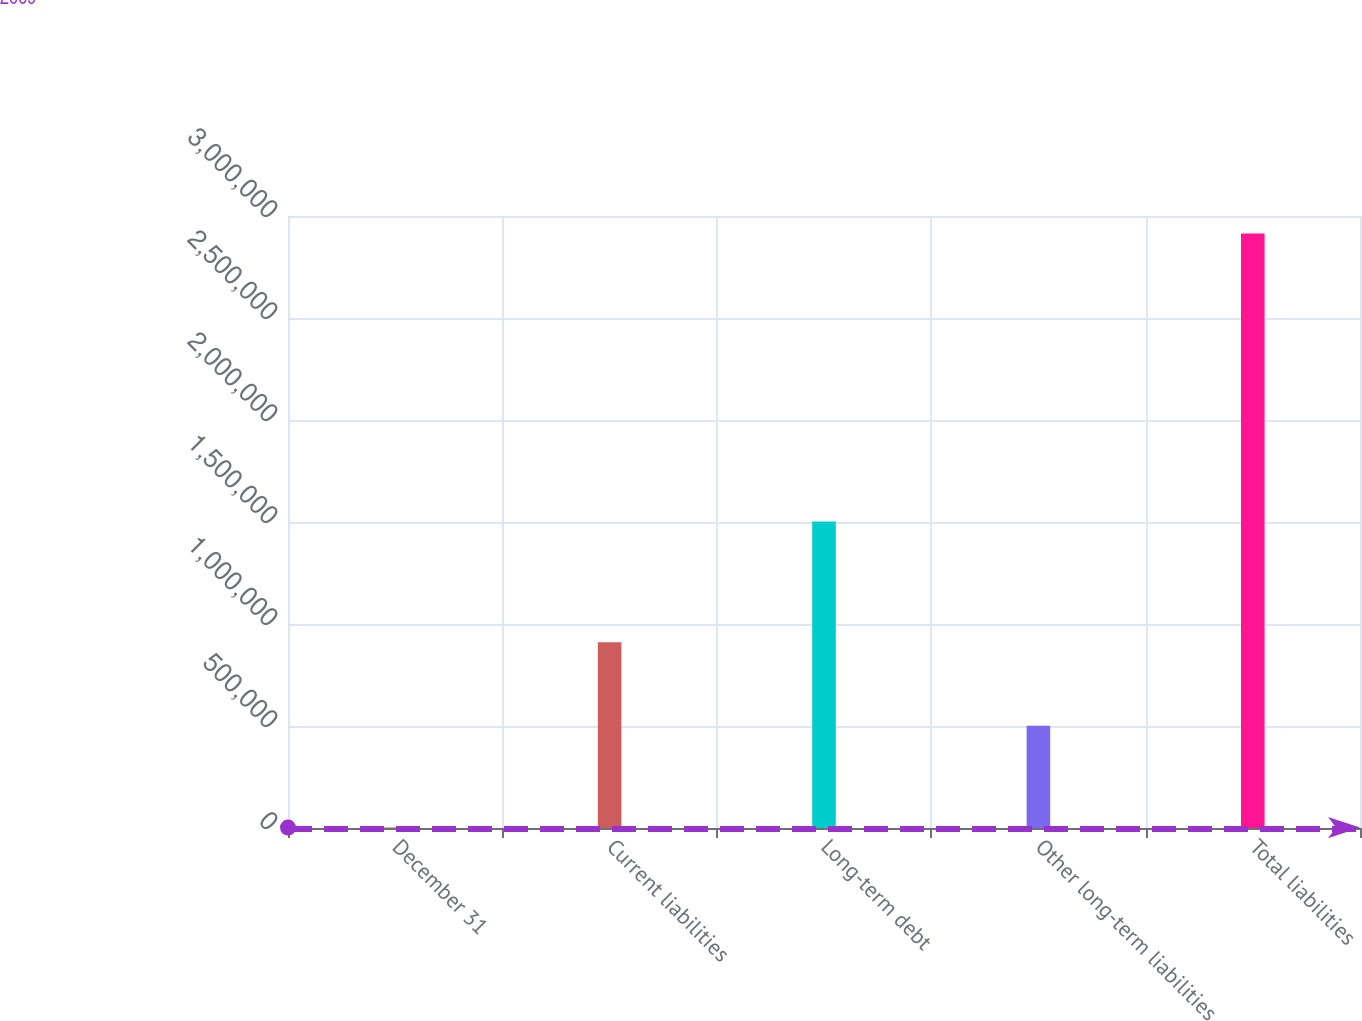<chart> <loc_0><loc_0><loc_500><loc_500><bar_chart><fcel>December 31<fcel>Current liabilities<fcel>Long-term debt<fcel>Other long-term liabilities<fcel>Total liabilities<nl><fcel>2009<fcel>910628<fcel>1.50273e+06<fcel>501334<fcel>2.91469e+06<nl></chart> 